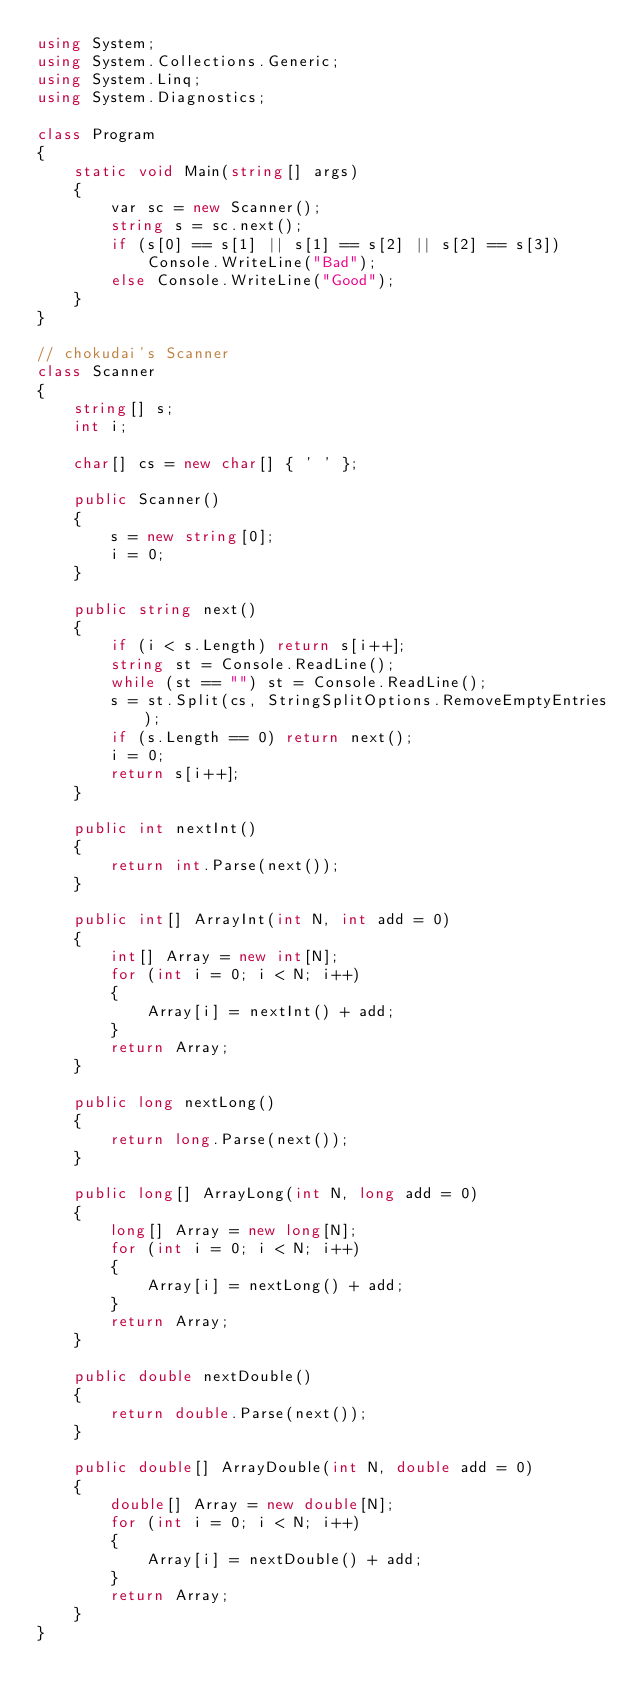Convert code to text. <code><loc_0><loc_0><loc_500><loc_500><_C#_>using System;
using System.Collections.Generic;
using System.Linq;
using System.Diagnostics;

class Program
{
    static void Main(string[] args)
    {
        var sc = new Scanner();
        string s = sc.next();
        if (s[0] == s[1] || s[1] == s[2] || s[2] == s[3])
            Console.WriteLine("Bad");
        else Console.WriteLine("Good");
    }
}

// chokudai's Scanner
class Scanner
{
    string[] s;
    int i;

    char[] cs = new char[] { ' ' };

    public Scanner()
    {
        s = new string[0];
        i = 0;
    }

    public string next()
    {
        if (i < s.Length) return s[i++];
        string st = Console.ReadLine();
        while (st == "") st = Console.ReadLine();
        s = st.Split(cs, StringSplitOptions.RemoveEmptyEntries);
        if (s.Length == 0) return next();
        i = 0;
        return s[i++];
    }

    public int nextInt()
    {
        return int.Parse(next());
    }

    public int[] ArrayInt(int N, int add = 0)
    {
        int[] Array = new int[N];
        for (int i = 0; i < N; i++)
        {
            Array[i] = nextInt() + add;
        }
        return Array;
    }

    public long nextLong()
    {
        return long.Parse(next());
    }

    public long[] ArrayLong(int N, long add = 0)
    {
        long[] Array = new long[N];
        for (int i = 0; i < N; i++)
        {
            Array[i] = nextLong() + add;
        }
        return Array;
    }

    public double nextDouble()
    {
        return double.Parse(next());
    }

    public double[] ArrayDouble(int N, double add = 0)
    {
        double[] Array = new double[N];
        for (int i = 0; i < N; i++)
        {
            Array[i] = nextDouble() + add;
        }
        return Array;
    }
}
</code> 